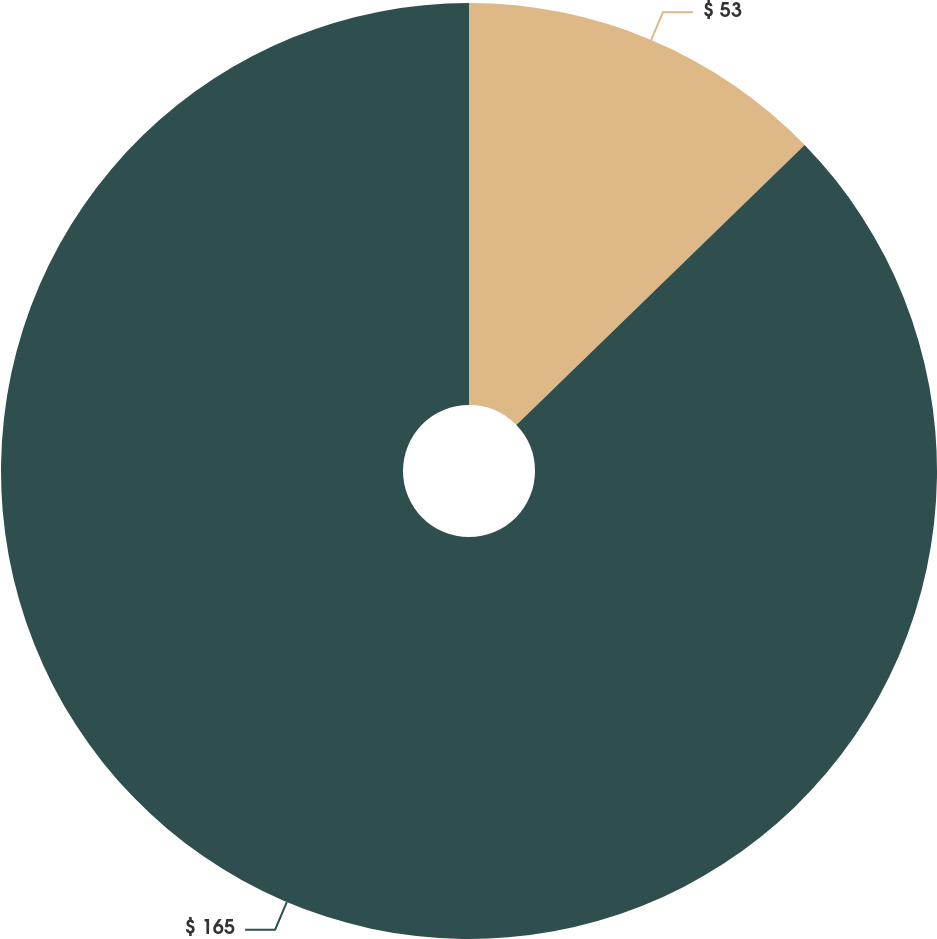<chart> <loc_0><loc_0><loc_500><loc_500><pie_chart><fcel>$ 53<fcel>$ 165<nl><fcel>12.73%<fcel>87.27%<nl></chart> 